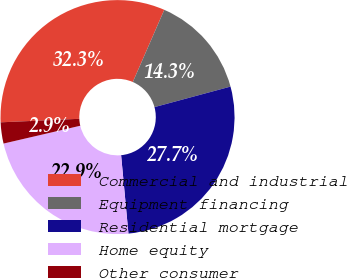Convert chart. <chart><loc_0><loc_0><loc_500><loc_500><pie_chart><fcel>Commercial and industrial<fcel>Equipment financing<fcel>Residential mortgage<fcel>Home equity<fcel>Other consumer<nl><fcel>32.25%<fcel>14.26%<fcel>27.71%<fcel>22.85%<fcel>2.92%<nl></chart> 